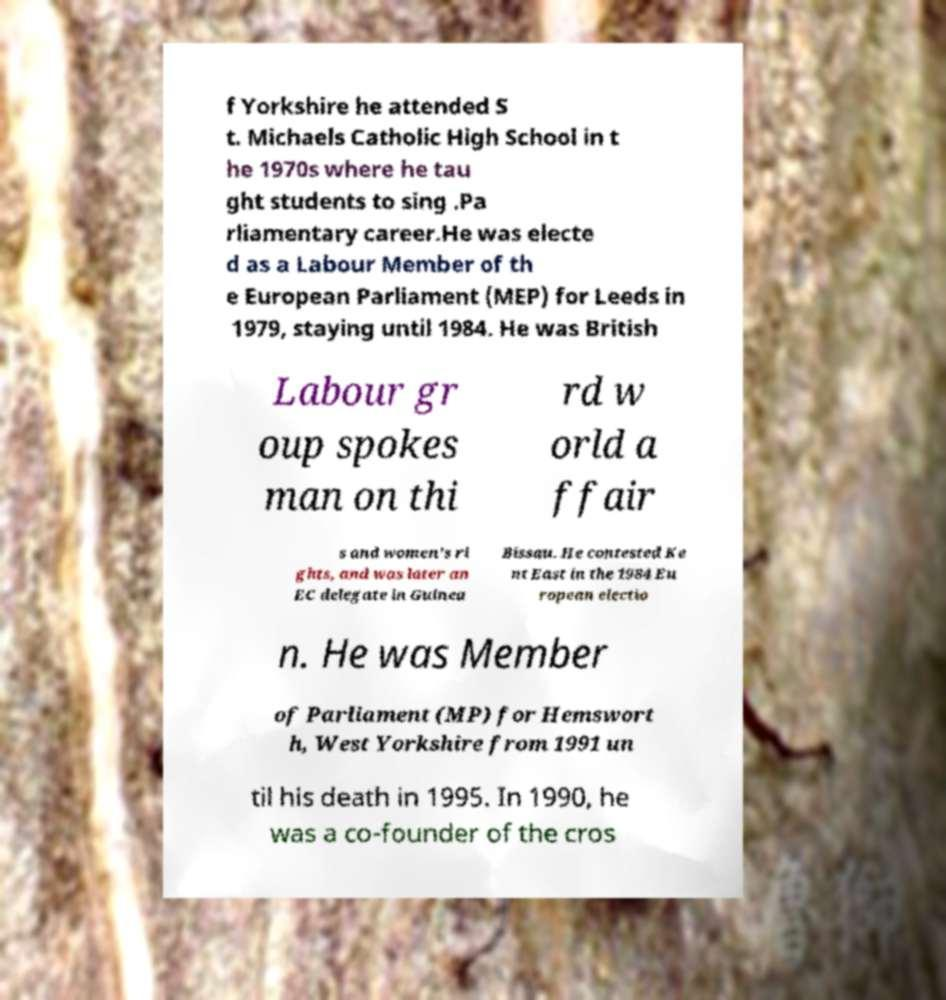I need the written content from this picture converted into text. Can you do that? f Yorkshire he attended S t. Michaels Catholic High School in t he 1970s where he tau ght students to sing .Pa rliamentary career.He was electe d as a Labour Member of th e European Parliament (MEP) for Leeds in 1979, staying until 1984. He was British Labour gr oup spokes man on thi rd w orld a ffair s and women's ri ghts, and was later an EC delegate in Guinea Bissau. He contested Ke nt East in the 1984 Eu ropean electio n. He was Member of Parliament (MP) for Hemswort h, West Yorkshire from 1991 un til his death in 1995. In 1990, he was a co-founder of the cros 